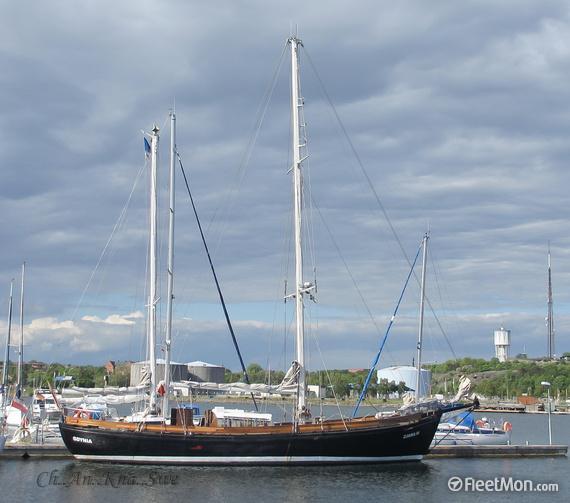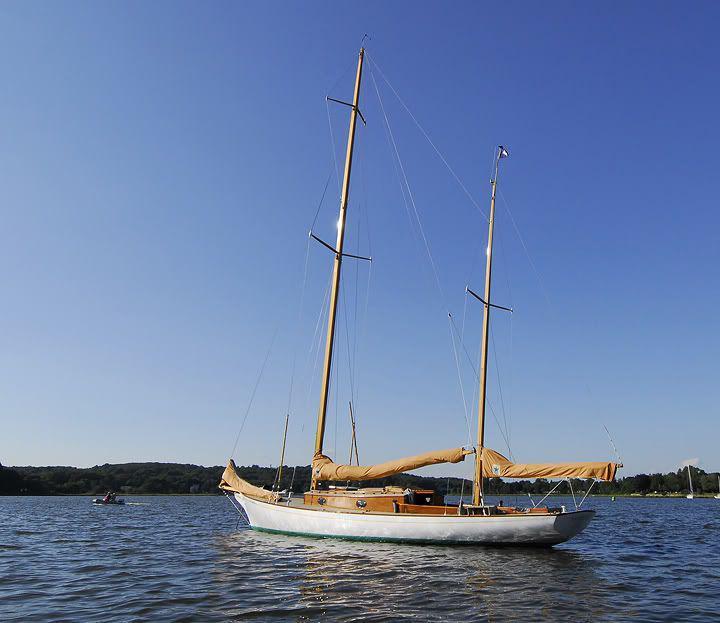The first image is the image on the left, the second image is the image on the right. Considering the images on both sides, is "A grassy hill is in the background of a sailboat." valid? Answer yes or no. Yes. The first image is the image on the left, the second image is the image on the right. Analyze the images presented: Is the assertion "The sails on one of the ships is fully extended." valid? Answer yes or no. No. 